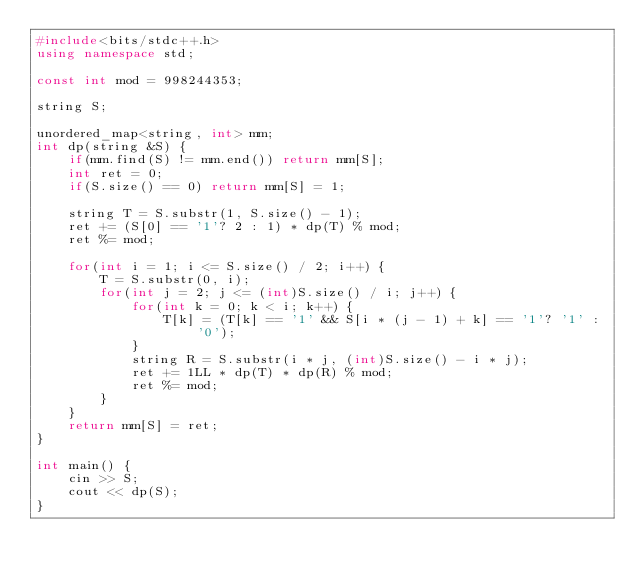<code> <loc_0><loc_0><loc_500><loc_500><_C++_>#include<bits/stdc++.h>
using namespace std;

const int mod = 998244353;

string S;

unordered_map<string, int> mm;
int dp(string &S) {
    if(mm.find(S) != mm.end()) return mm[S];
    int ret = 0;
    if(S.size() == 0) return mm[S] = 1;

    string T = S.substr(1, S.size() - 1);
    ret += (S[0] == '1'? 2 : 1) * dp(T) % mod;
    ret %= mod;

    for(int i = 1; i <= S.size() / 2; i++) {
        T = S.substr(0, i);
        for(int j = 2; j <= (int)S.size() / i; j++) {
            for(int k = 0; k < i; k++) {
                T[k] = (T[k] == '1' && S[i * (j - 1) + k] == '1'? '1' : '0');
            }
            string R = S.substr(i * j, (int)S.size() - i * j);
            ret += 1LL * dp(T) * dp(R) % mod;
            ret %= mod;
        }
    }
    return mm[S] = ret;
}

int main() {
    cin >> S;
    cout << dp(S);
}
</code> 